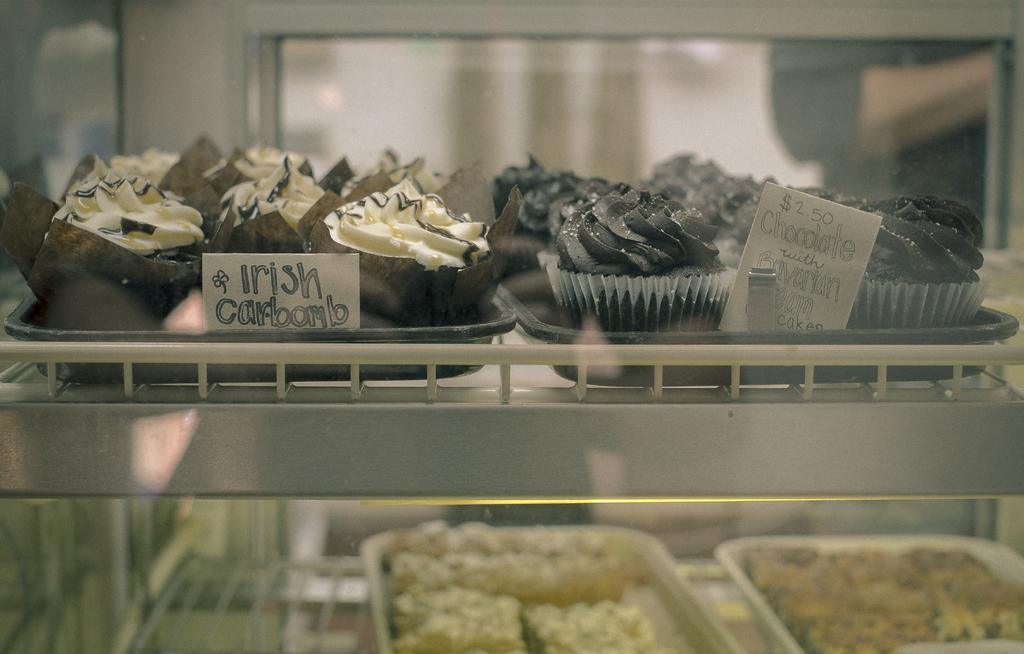What type of food can be seen in the image? There are cupcakes and desserts in the image. How are the cupcakes and desserts arranged in the image? The cupcakes and desserts are placed on shelves. What else can be seen in the image besides the cupcakes and desserts? There are trays in the image. Is there a fireman putting out a fire in the image? No, there is no fireman or fire in the image. Can you see a crook stealing any of the cupcakes or desserts in the image? No, there is no crook or theft depicted in the image. 